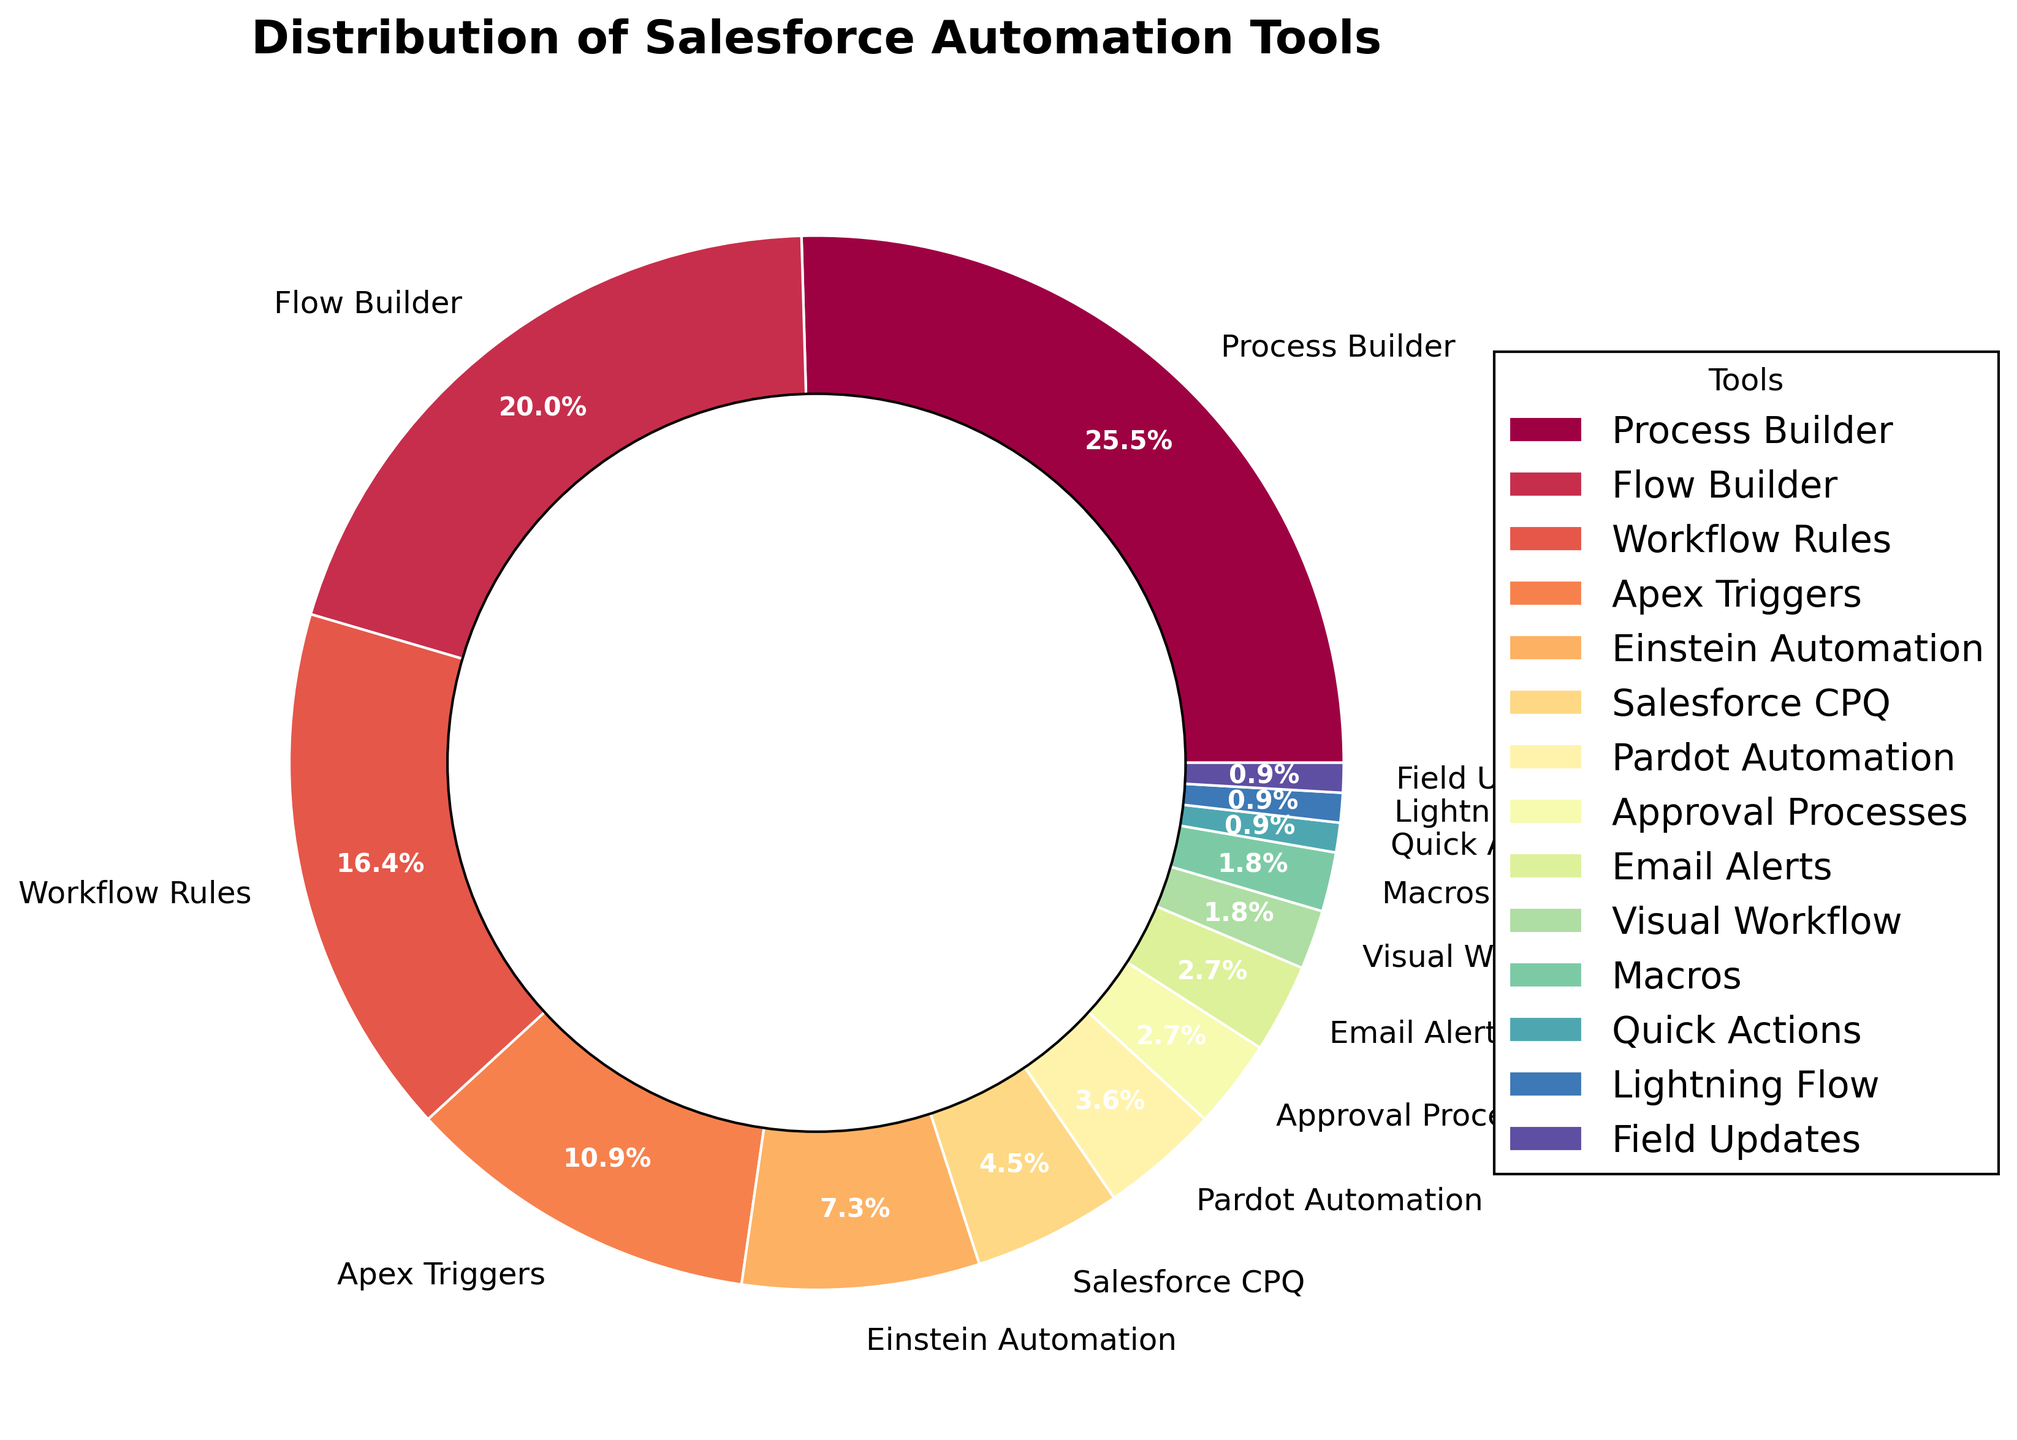What percentage of sales teams use Process Builder? Process Builder has a wedge in the pie chart labeled with its percentage.
Answer: 28% Which automation tool is used by fewer teams, Pardot Automation or Approval Processes? By observing the percentages in the figure, Pardot Automation is 4% and Approval Processes is 3%, so Approval Processes is used by fewer teams.
Answer: Approval Processes How does the usage of Flow Builder compare to that of Workflow Rules? Flow Builder is used by 22% of teams, whereas Workflow Rules is used by 18%. Since 22% is greater than 18%, Flow Builder is used by more teams.
Answer: Flow Builder is used more What is the combined percentage of teams using Email Alerts, Visual Workflow, and Macros? Add the percentages of Email Alerts (3%), Visual Workflow (2%), and Macros (2%): 3% + 2% + 2% = 7%.
Answer: 7% Are there more teams using Einstein Automation than Salesforce CPQ? The percentage for Einstein Automation is 8%, whereas Salesforce CPQ is used by 5% of teams. Since 8% is greater than 5%, more teams use Einstein Automation.
Answer: Yes Which tool is used by exactly 1% of the teams? Refer to the wedge in the pie chart labeled with 1%. The tools are Quick Actions, Lightning Flow, and Field Updates.
Answer: Quick Actions, Lightning Flow, Field Updates By what percentage does the usage of Process Builder exceed Apex Triggers? Process Builder is 28% and Apex Triggers is 12%. The difference is 28% - 12% = 16%.
Answer: 16% How does the color of the wedge for Salesforce CPQ compare to that of Pardot Automation? Identifying from the color spectrum, Salesforce CPQ is represented by a color closer to the middle of the spectrum while Pardot Automation is a color further towards the end.
Answer: Salesforce CPQ is a middle-spectrum color, Pardot Automation is an end-spectrum color What is the sum percentage of all tools used by less than 5% of teams each? Add the percentages of Salesforce CPQ (5%), Pardot Automation (4%), Approval Processes (3%), Email Alerts (3%), Visual Workflow (2%), Macros (2%), Quick Actions (1%), Lightning Flow (1%), and Field Updates (1%): 5% + 4% + 3% + 3% + 2% + 2% + 1% + 1% + 1% = 22%.
Answer: 22% 